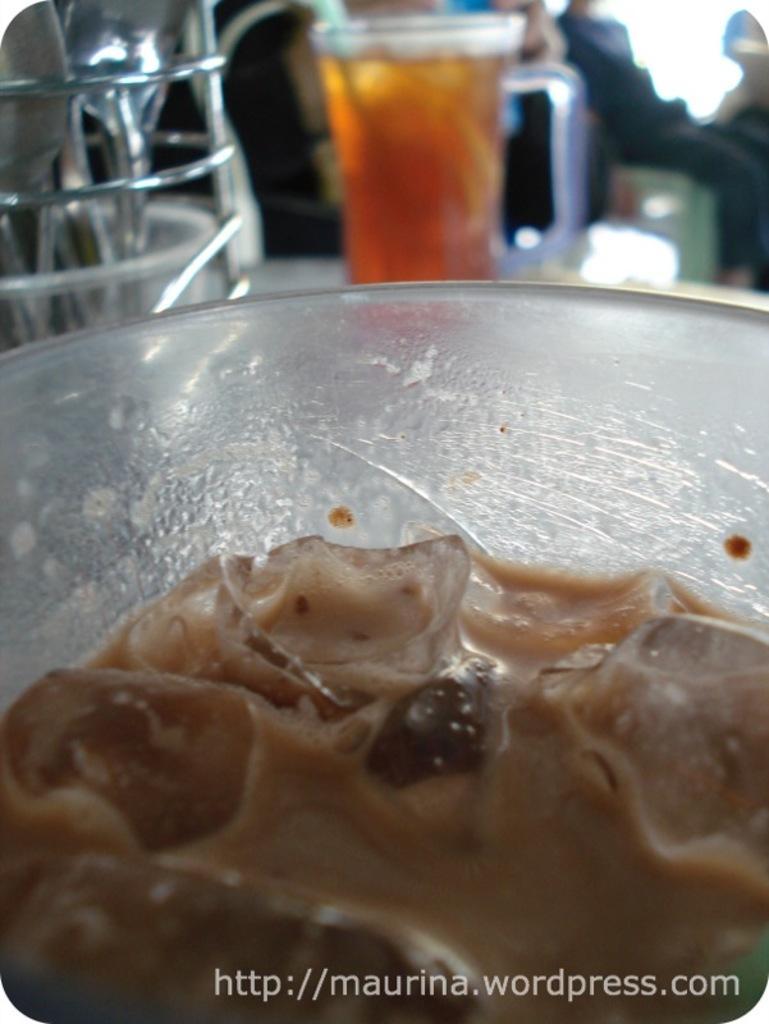How would you summarize this image in a sentence or two? In the picture we can see inside the glass with a cream shake and outside it, we can see a glass with a drink on the table and beside it, we can see a stand with spoons in it and behind the glass we can see some people are sitting and they are not clearly visible. 